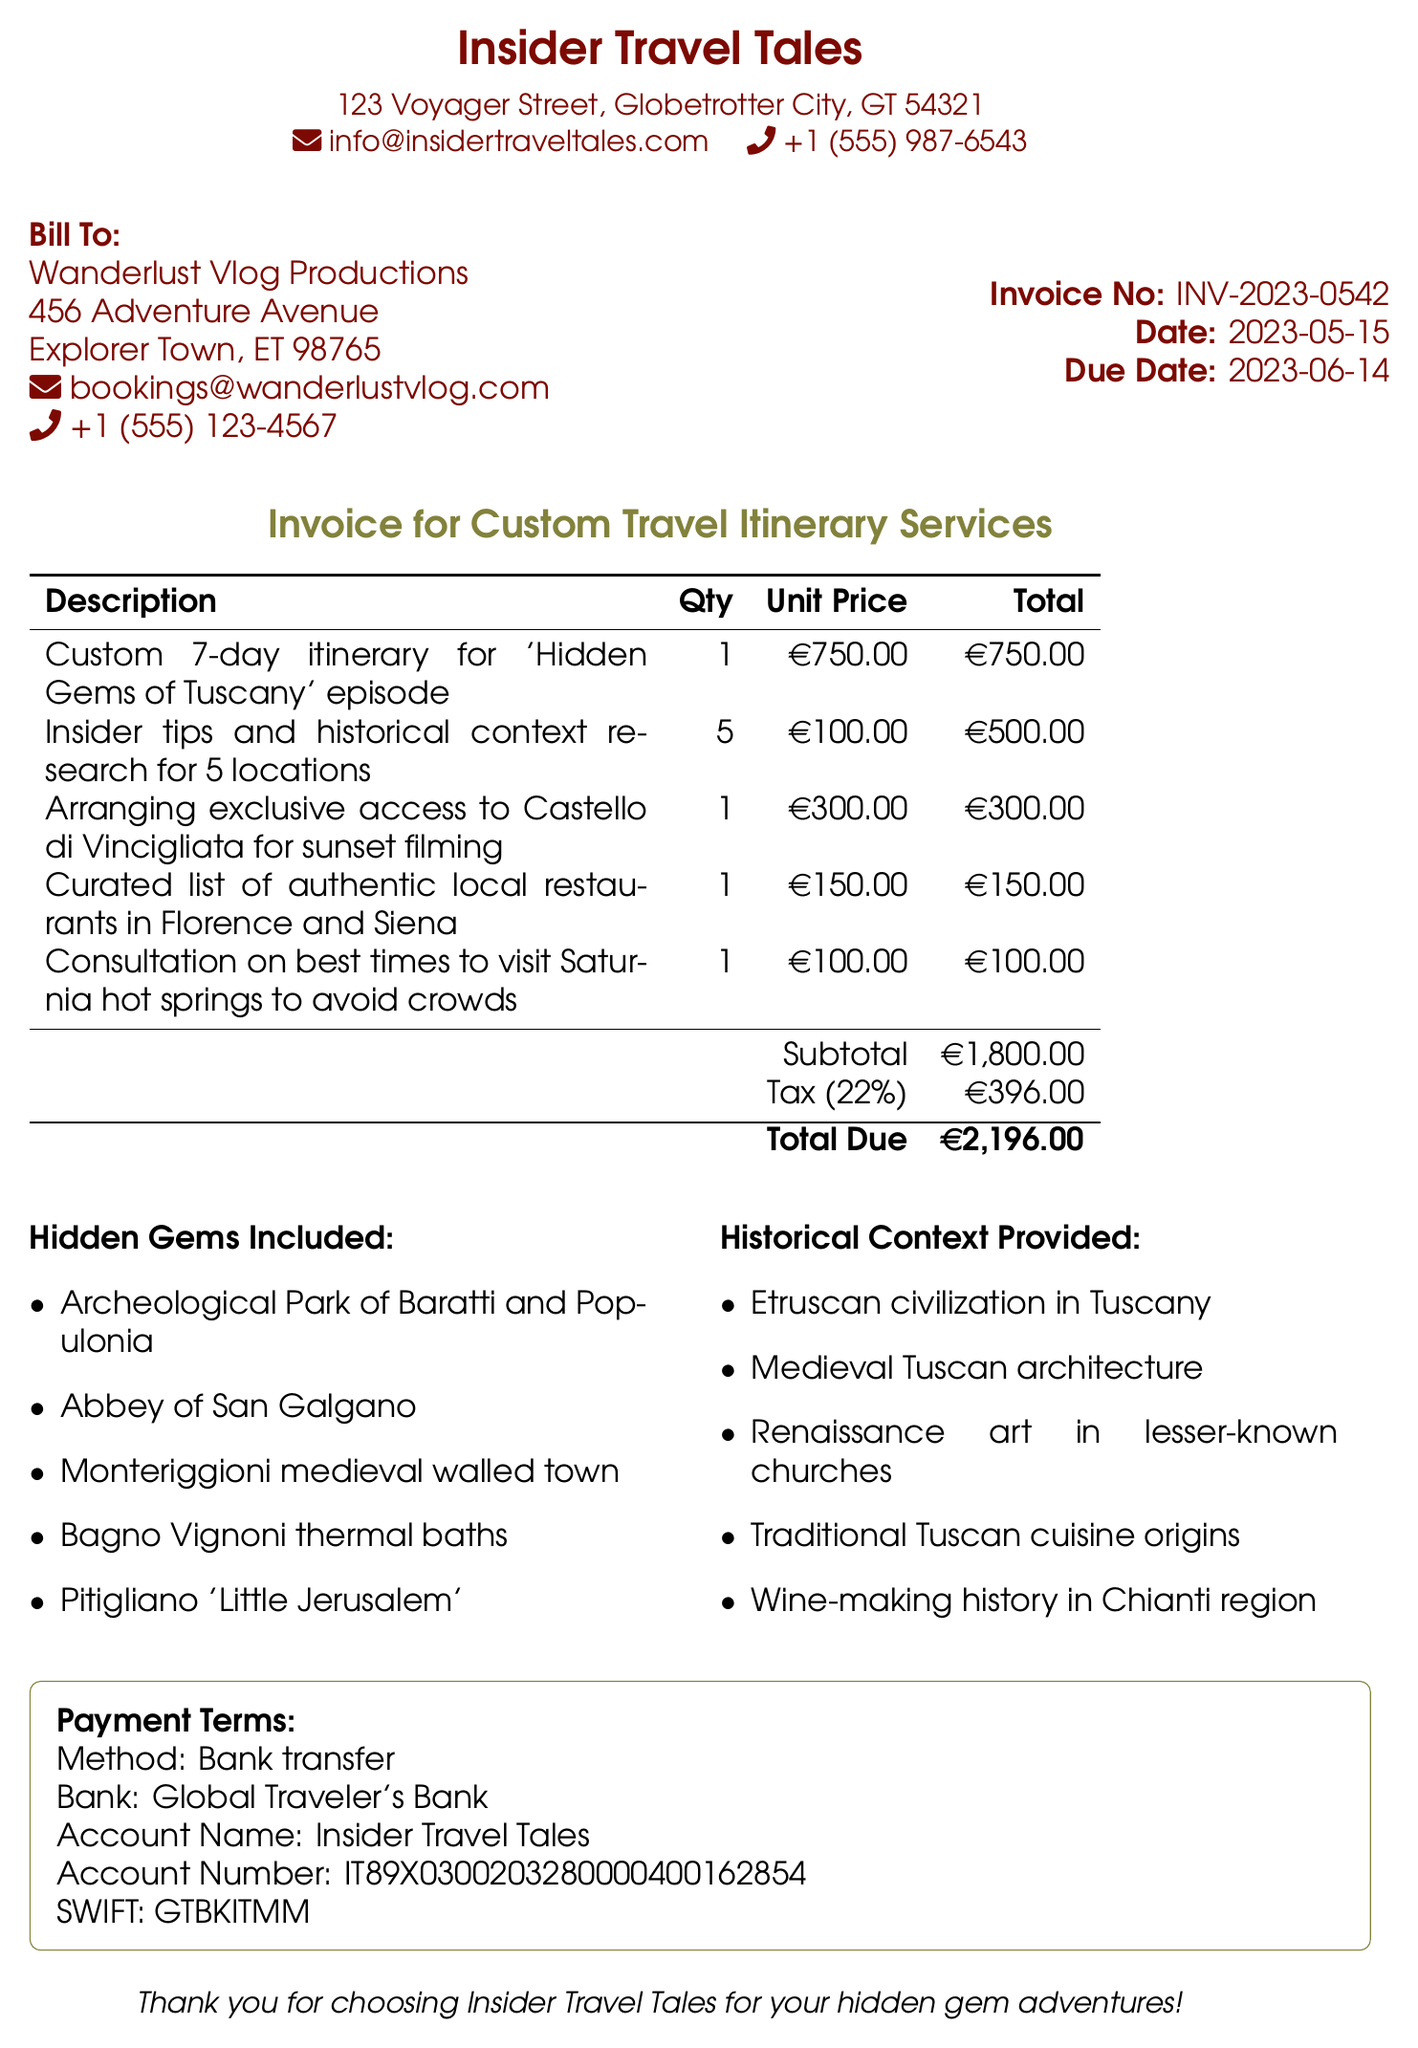What is the invoice number? The invoice number is located in the invoice details section of the document.
Answer: INV-2023-0542 What is the due date? The due date is specified in the invoice details section.
Answer: 2023-06-14 Who is the service provider? The service provider's name is listed prominently at the beginning of the document.
Answer: Insider Travel Tales What is the total amount due? The total amount due is mentioned in the invoice total section.
Answer: 2,196.00 How many locations received insider tips and historical context research? This information can be found in the services listed in the document.
Answer: 5 What type of access was arranged for sunset filming? The document describes specific arrangements made for filming in its services section.
Answer: Exclusive access to Castello di Vincigliata What payment method is specified? The payment terms section outlines the method of payment.
Answer: Bank transfer Which hidden gem is mentioned first? The hidden gems are listed in a bulleted format within the additional information section.
Answer: Archeological Park of Baratti and Populonia What is the tax rate applied? The tax rate is mentioned in the total amount section of the document.
Answer: 22% 